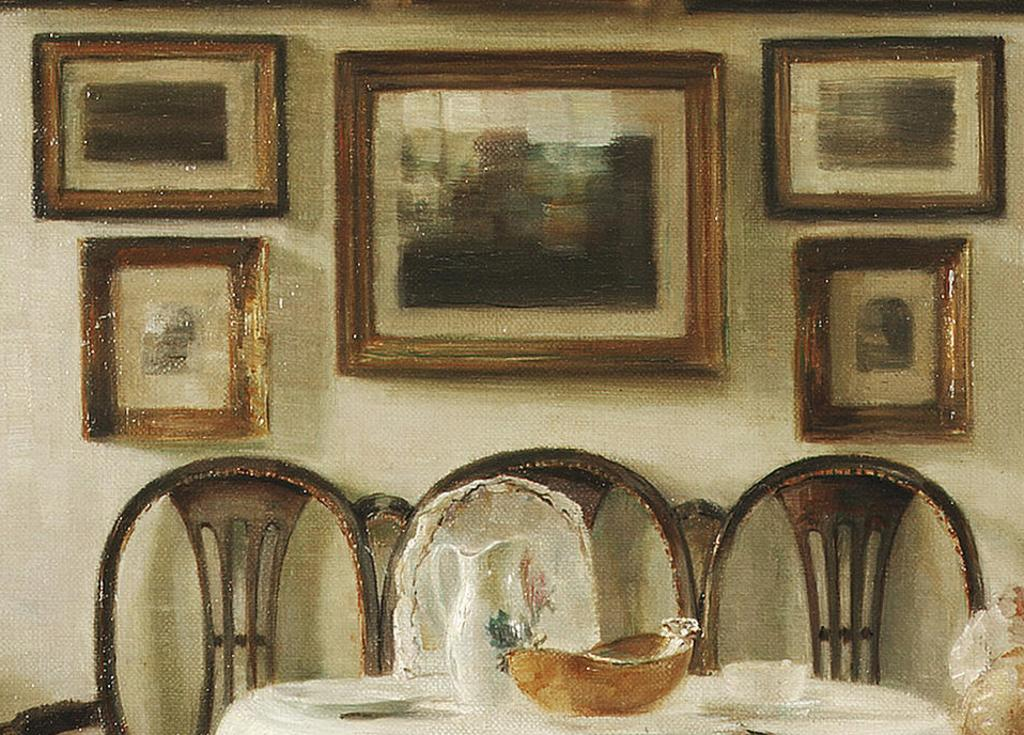What type of furniture is present in the image? There are chairs and a table in the image. What is placed on the table? There are bowls and a mug on the table. Are there any decorations or items on the wall in the image? Yes, there are frames on the wall in the image. How many tickets can be seen on the table in the image? There are no tickets present on the table in the image. What type of sorting activity is happening with the frames on the wall in the image? There is no sorting activity happening with the frames on the wall in the image; they are simply decorative elements. 